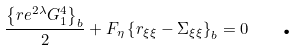<formula> <loc_0><loc_0><loc_500><loc_500>\frac { \left \{ r e ^ { 2 \lambda } G _ { 1 } ^ { 4 } \right \} _ { b } } { 2 } + F _ { \eta } \left \{ r _ { \xi \xi } - \Sigma _ { \xi \xi } \right \} _ { b } = 0 \quad \text {.}</formula> 